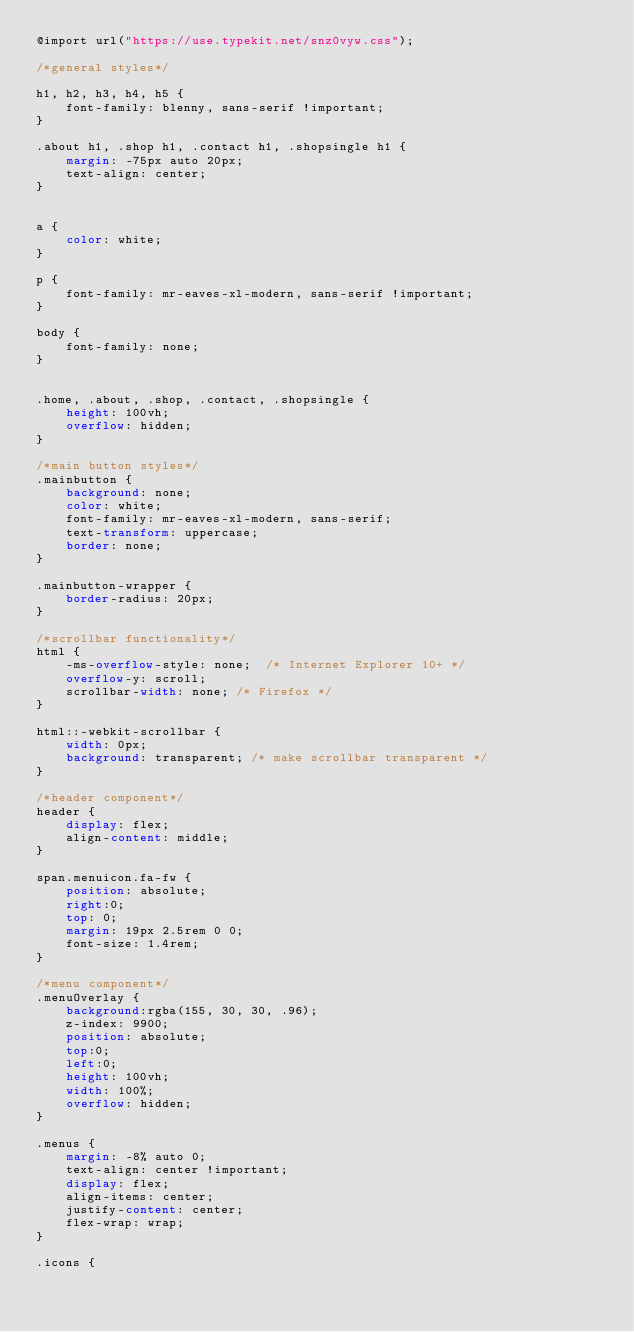<code> <loc_0><loc_0><loc_500><loc_500><_CSS_>@import url("https://use.typekit.net/snz0vyw.css");

/*general styles*/

h1, h2, h3, h4, h5 {
    font-family: blenny, sans-serif !important; 
}

.about h1, .shop h1, .contact h1, .shopsingle h1 {
    margin: -75px auto 20px;
    text-align: center;
}


a {
    color: white;
}

p {
    font-family: mr-eaves-xl-modern, sans-serif !important; 
}

body {
    font-family: none;
}


.home, .about, .shop, .contact, .shopsingle {
    height: 100vh;
    overflow: hidden;
}

/*main button styles*/
.mainbutton {
    background: none;
    color: white;
    font-family: mr-eaves-xl-modern, sans-serif;
    text-transform: uppercase;
    border: none;
}

.mainbutton-wrapper {
    border-radius: 20px;
}

/*scrollbar functionality*/
html {
    -ms-overflow-style: none;  /* Internet Explorer 10+ */
    overflow-y: scroll;
    scrollbar-width: none; /* Firefox */
}

html::-webkit-scrollbar {
    width: 0px;
    background: transparent; /* make scrollbar transparent */
}

/*header component*/
header {
    display: flex;
    align-content: middle;
}

span.menuicon.fa-fw {
    position: absolute;
    right:0;
    top: 0;
    margin: 19px 2.5rem 0 0;
    font-size: 1.4rem;
}

/*menu component*/
.menuOverlay {
    background:rgba(155, 30, 30, .96);
    z-index: 9900;
    position: absolute;
    top:0;
    left:0;
    height: 100vh;
    width: 100%;
    overflow: hidden;
}

.menus {
    margin: -8% auto 0;
    text-align: center !important;
    display: flex;
    align-items: center;
    justify-content: center;
    flex-wrap: wrap;
}

.icons {</code> 